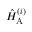Convert formula to latex. <formula><loc_0><loc_0><loc_500><loc_500>\hat { H } _ { A } ^ { ( i ) }</formula> 